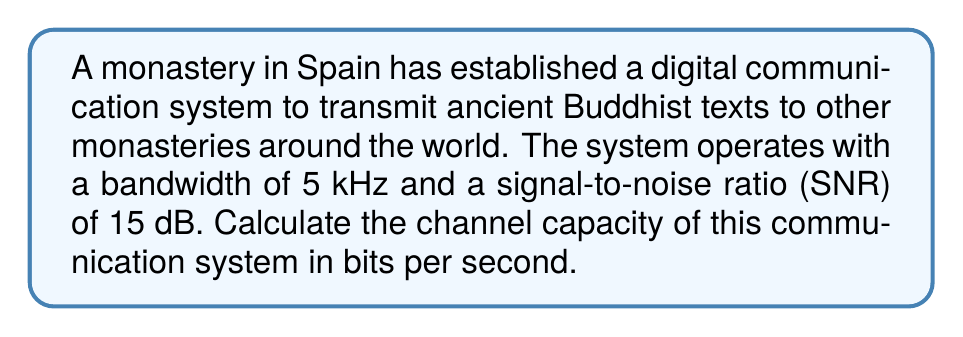What is the answer to this math problem? To solve this problem, we'll use the Shannon-Hartley theorem, which gives us the channel capacity for a communication system with additive white Gaussian noise.

The Shannon-Hartley theorem states that:

$$C = B \log_2(1 + SNR)$$

Where:
$C$ = Channel capacity (bits per second)
$B$ = Bandwidth (Hz)
$SNR$ = Signal-to-noise ratio (linear scale)

Given:
- Bandwidth, $B = 5$ kHz = $5000$ Hz
- SNR = 15 dB

Step 1: Convert SNR from decibels to linear scale
$SNR_{linear} = 10^{SNR_{dB}/10} = 10^{15/10} \approx 31.6228$

Step 2: Apply the Shannon-Hartley theorem
$$\begin{align*}
C &= B \log_2(1 + SNR) \\
&= 5000 \cdot \log_2(1 + 31.6228) \\
&= 5000 \cdot \log_2(32.6228) \\
&\approx 5000 \cdot 5.0279 \\
&\approx 25139.5 \text{ bits per second}
\end{align*}$$

Therefore, the channel capacity of the communication system is approximately 25,139.5 bits per second.
Answer: $C \approx 25,139.5$ bits per second 